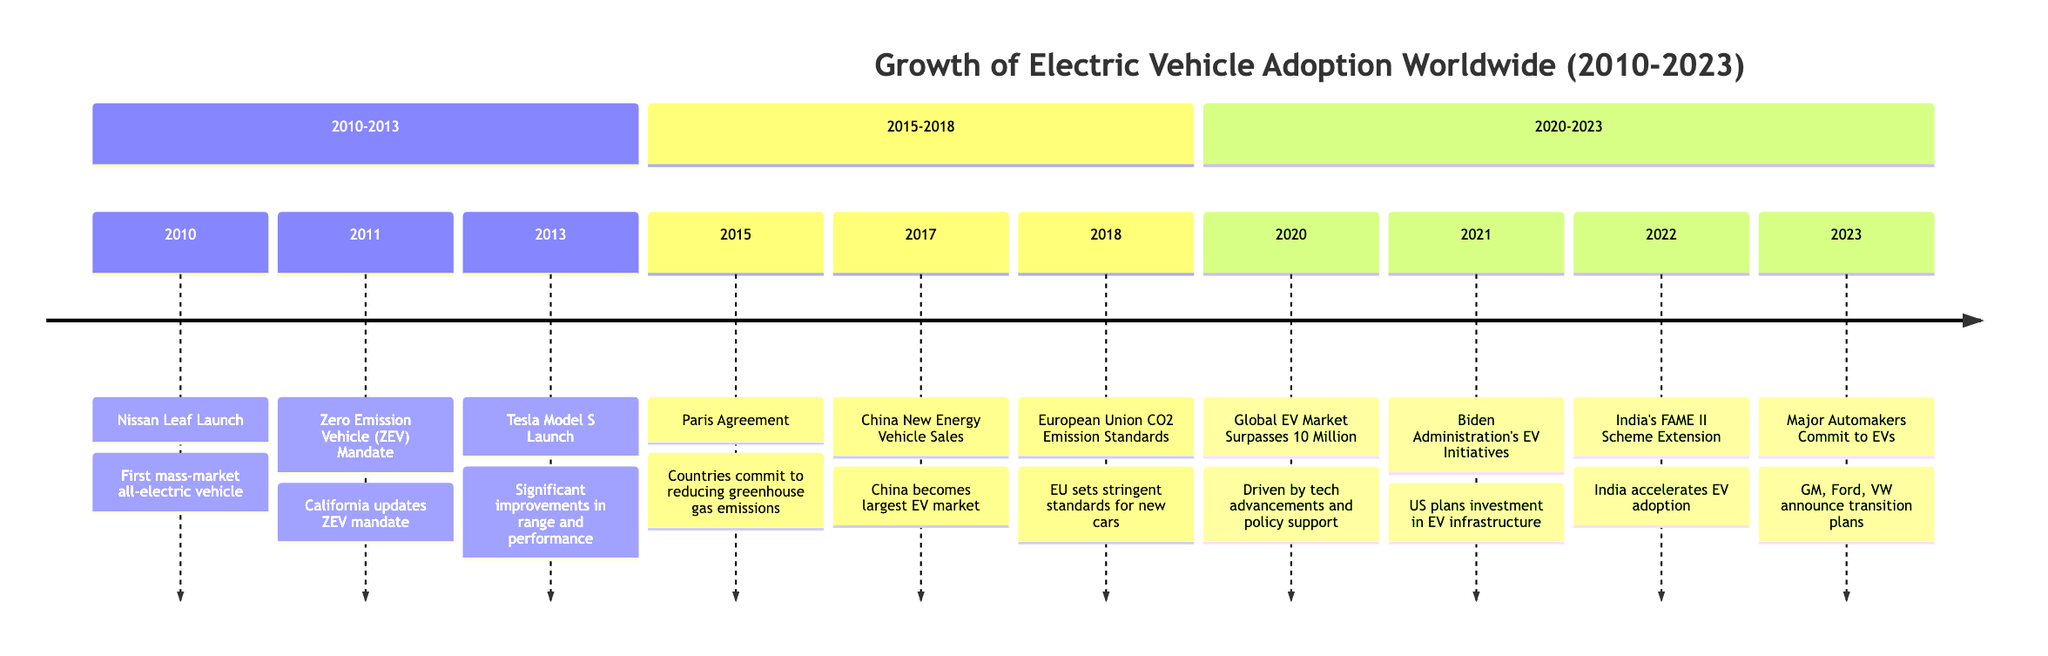What event marked the launch of the first mass-market all-electric vehicle? The diagram indicates that the Nissan Leaf was launched in 2010, representing the first mass-market all-electric vehicle.
Answer: Nissan Leaf Launch In which year did California update its Zero Emission Vehicle mandate? According to the timeline, the Zero Emission Vehicle (ZEV) Mandate was updated in 2011.
Answer: 2011 How many electric vehicles were sold in China in 2017? The timeline states that over 777,000 electric vehicles were sold in China in 2017, making it the largest market for EVs at that time.
Answer: 777,000 What significant international agreement in 2015 aimed at reducing greenhouse gas emissions? The timeline specifies that the Paris Agreement, established in 2015, involved countries committing to reducing greenhouse gas emissions.
Answer: Paris Agreement Which automakers committed to transitioning to all-electric fleets in 2023? The diagram mentions that major automakers like GM, Ford, and Volkswagen announced commitments to transition to all-electric fleets in 2023.
Answer: GM, Ford, Volkswagen What was the global stock of electric vehicles by 2020? The diagram shows that the global stock of electric vehicles surpassed 10 million units by the year 2020.
Answer: 10 million Which country's government extended the FAME II scheme in 2022? As per the timeline, the FAME II scheme was extended by the government of India to accelerate EV adoption in 2022.
Answer: India What improvement in EV technology was associated with the launch of the Tesla Model S in 2013? The timeline indicates that the Tesla Model S offered significant improvements in range and performance upon its launch in 2013.
Answer: Range and performance What specific action did the Biden Administration take regarding electric vehicles in 2021? The diagram details that the Biden Administration announced plans to invest in electric vehicle infrastructure and incentives in 2021.
Answer: Investment in infrastructure and incentives 